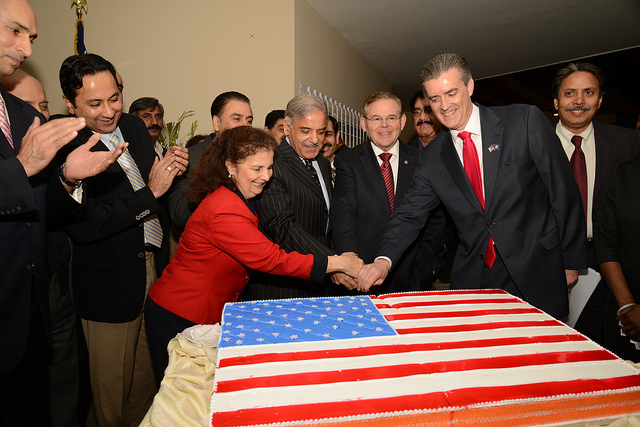<image>What season is this? The season in the image is ambiguous. It could be any season. What season is this? I don't know what season it is. It could be summer, fall or winter. 